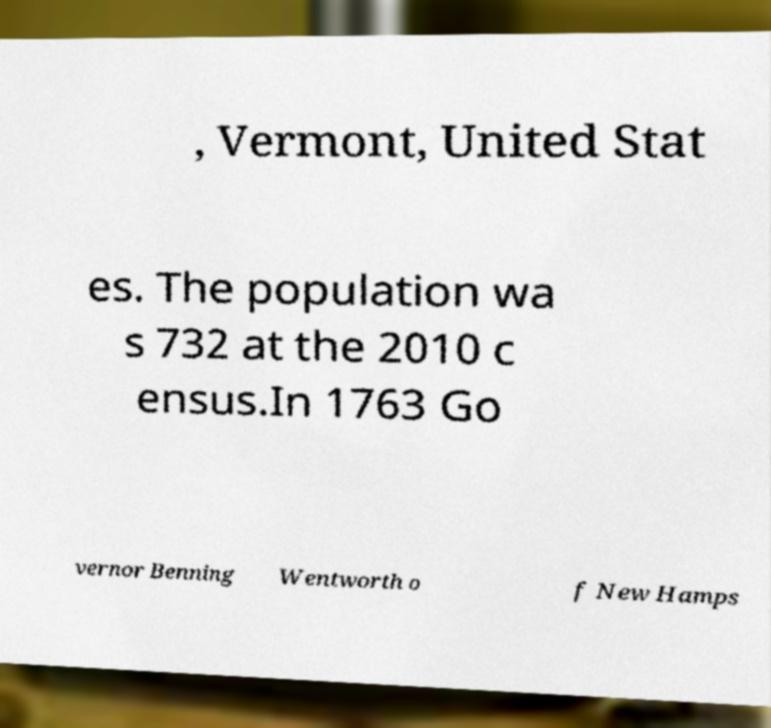I need the written content from this picture converted into text. Can you do that? , Vermont, United Stat es. The population wa s 732 at the 2010 c ensus.In 1763 Go vernor Benning Wentworth o f New Hamps 